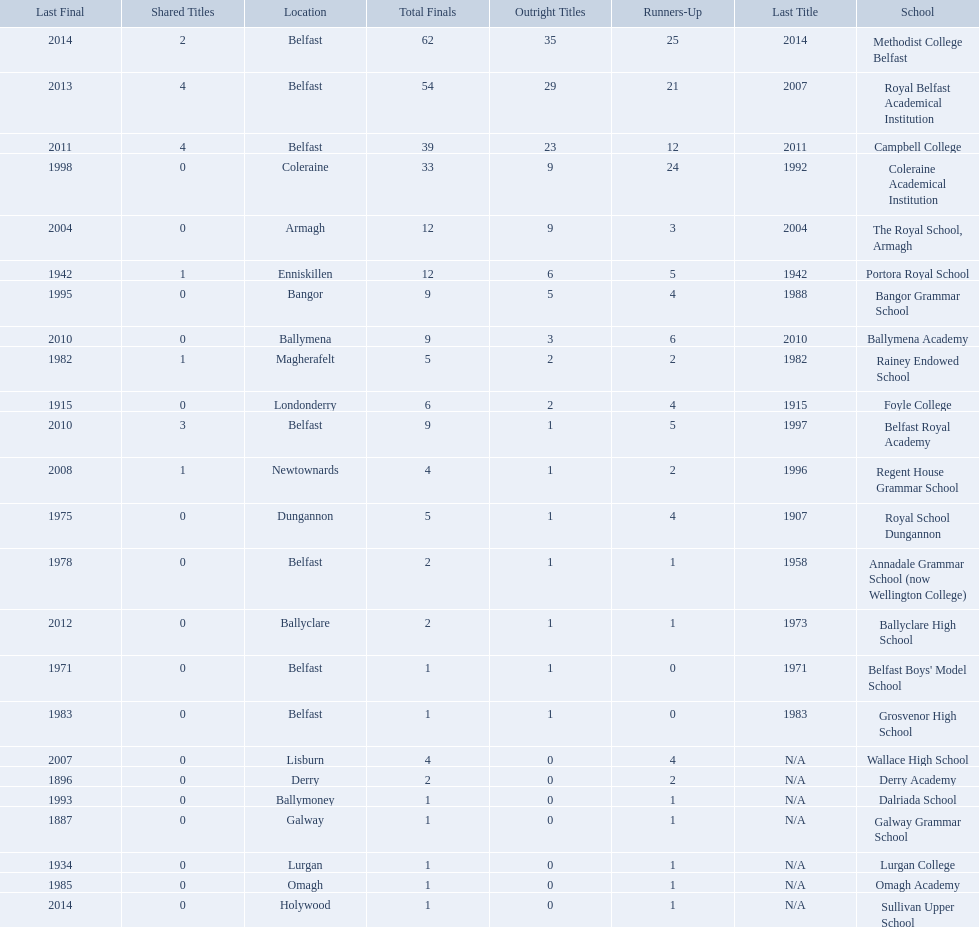How many outright titles does coleraine academical institution have? 9. What other school has this amount of outright titles The Royal School, Armagh. 